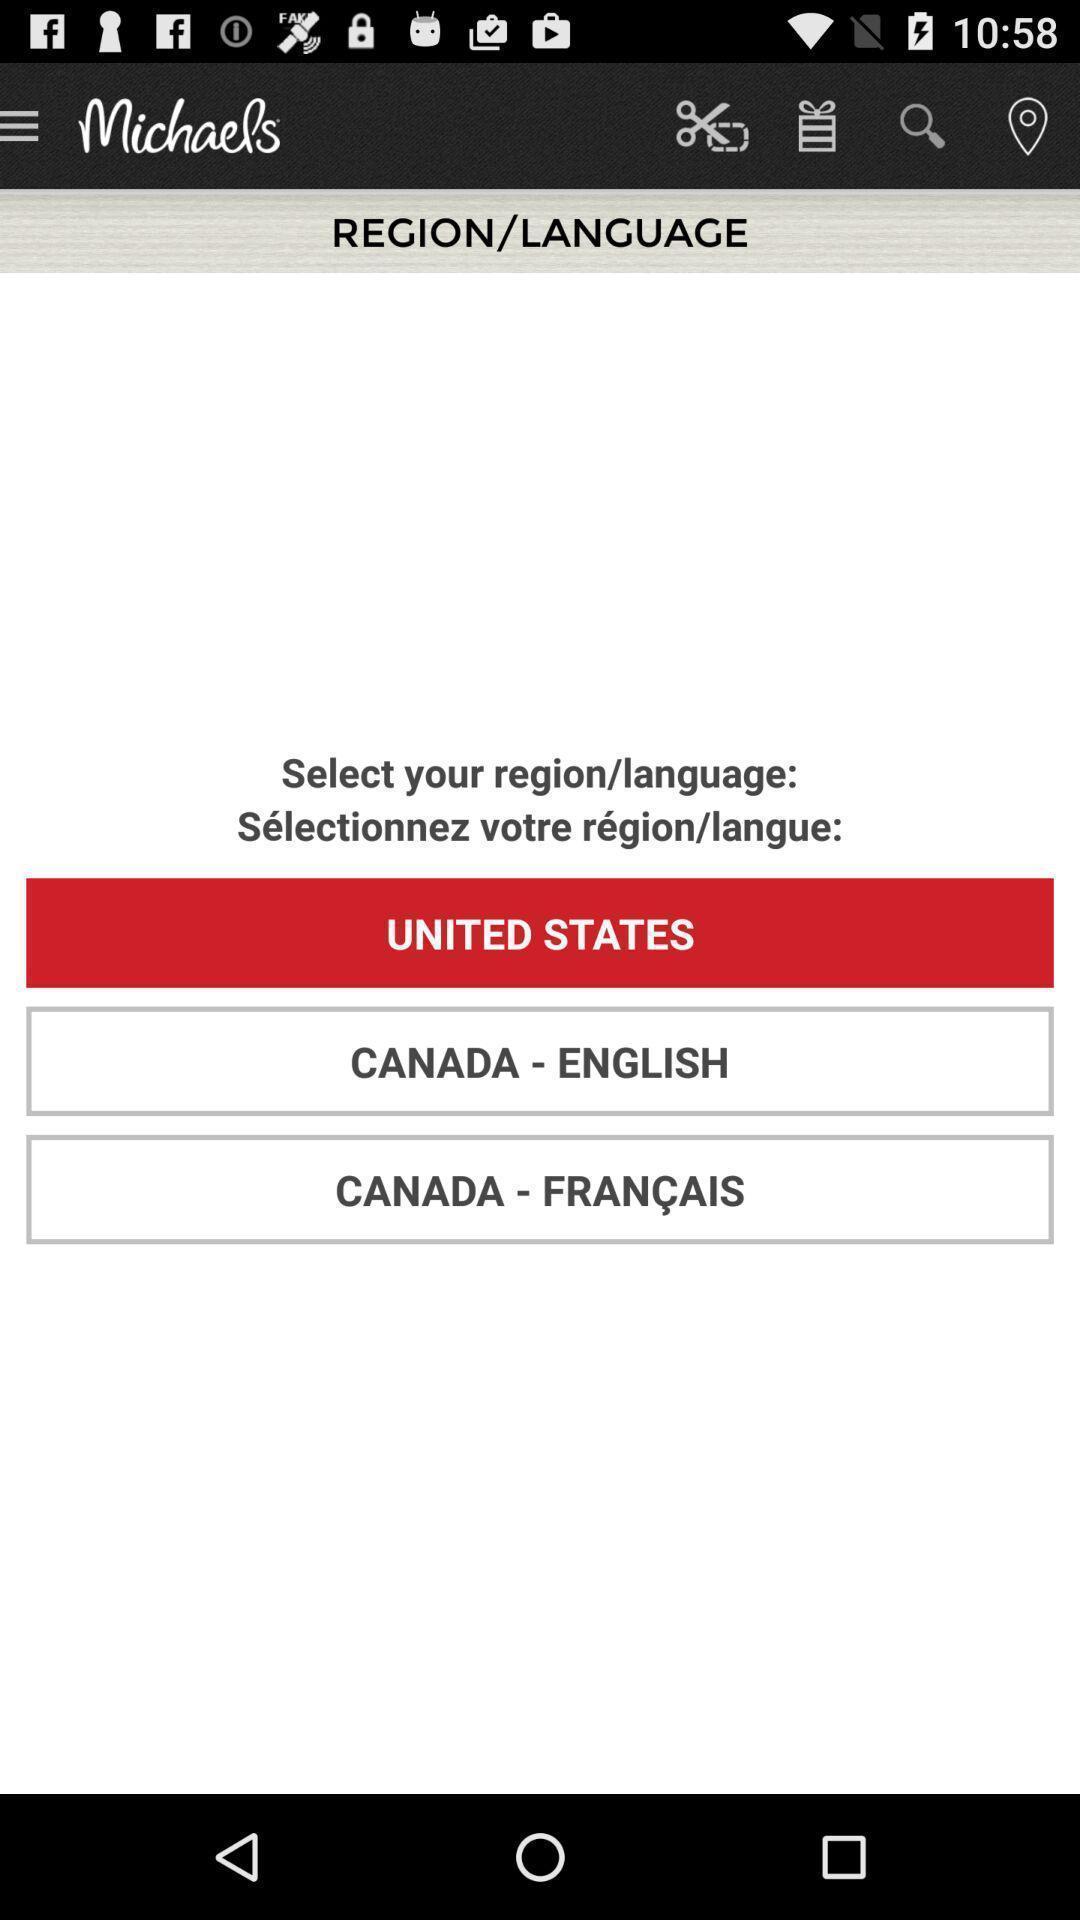What is the overall content of this screenshot? Page showing select your region. 